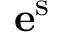Convert formula to latex. <formula><loc_0><loc_0><loc_500><loc_500>e ^ { s }</formula> 